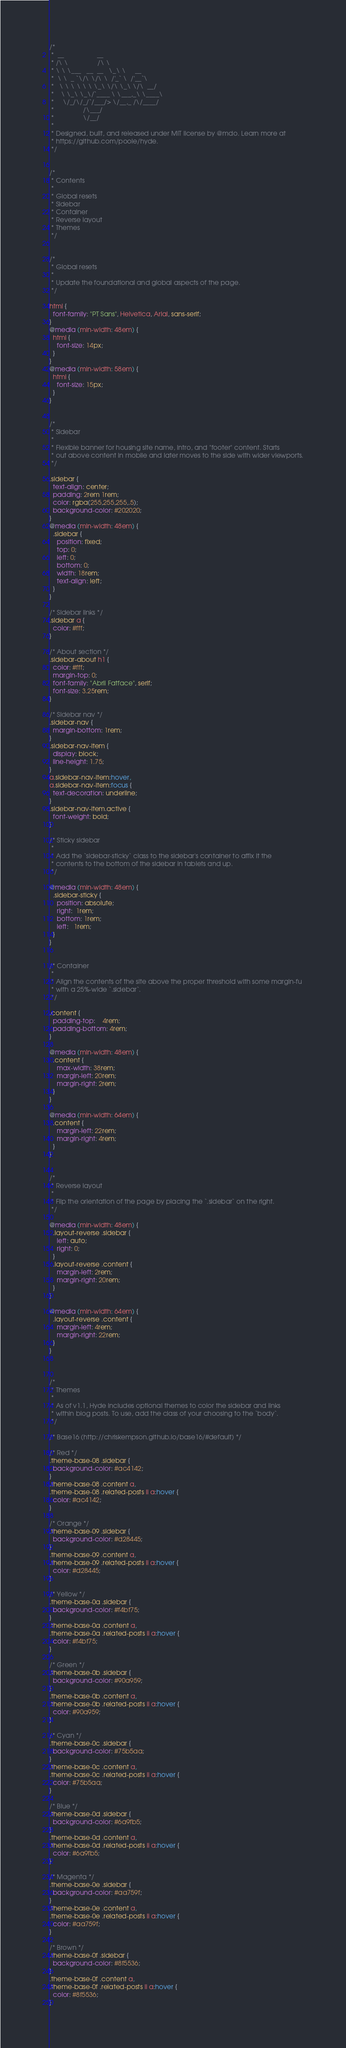Convert code to text. <code><loc_0><loc_0><loc_500><loc_500><_CSS_>/*
 *  __                  __
 * /\ \                /\ \
 * \ \ \___   __  __   \_\ \     __
 *  \ \  _ `\/\ \/\ \  /'_` \  /'__`\
 *   \ \ \ \ \ \ \_\ \/\ \_\ \/\  __/
 *    \ \_\ \_\/`____ \ \___,_\ \____\
 *     \/_/\/_/`/___/> \/__,_ /\/____/
 *                /\___/
 *                \/__/
 *
 * Designed, built, and released under MIT license by @mdo. Learn more at
 * https://github.com/poole/hyde.
 */


/*
 * Contents
 *
 * Global resets
 * Sidebar
 * Container
 * Reverse layout
 * Themes
 */


/*
 * Global resets
 *
 * Update the foundational and global aspects of the page.
 */

html {
  font-family: "PT Sans", Helvetica, Arial, sans-serif;
}
@media (min-width: 48em) {
  html {
    font-size: 14px;
  }
}
@media (min-width: 58em) {
  html {
    font-size: 15px;
  }
}


/*
 * Sidebar
 *
 * Flexible banner for housing site name, intro, and "footer" content. Starts
 * out above content in mobile and later moves to the side with wider viewports.
 */

.sidebar {
  text-align: center;
  padding: 2rem 1rem;
  color: rgba(255,255,255,.5);
  background-color: #202020;
}
@media (min-width: 48em) {
  .sidebar {
    position: fixed;
    top: 0;
    left: 0;
    bottom: 0;
    width: 18rem;
    text-align: left;
  }
}

/* Sidebar links */
.sidebar a {
  color: #fff;
}

/* About section */
.sidebar-about h1 {
  color: #fff;
  margin-top: 0;
  font-family: "Abril Fatface", serif;
  font-size: 3.25rem;
}

/* Sidebar nav */
.sidebar-nav {
  margin-bottom: 1rem;
}
.sidebar-nav-item {
  display: block;
  line-height: 1.75;
}
a.sidebar-nav-item:hover,
a.sidebar-nav-item:focus {
  text-decoration: underline;
}
.sidebar-nav-item.active {
  font-weight: bold;
}

/* Sticky sidebar
 *
 * Add the `sidebar-sticky` class to the sidebar's container to affix it the
 * contents to the bottom of the sidebar in tablets and up.
 */

@media (min-width: 48em) {
  .sidebar-sticky {
    position: absolute;
    right:  1rem;
    bottom: 1rem;
    left:   1rem;
  }
}


/* Container
 *
 * Align the contents of the site above the proper threshold with some margin-fu
 * with a 25%-wide `.sidebar`.
 */

.content {
  padding-top:    4rem;
  padding-bottom: 4rem;
}

@media (min-width: 48em) {
  .content {
    max-width: 38rem;
    margin-left: 20rem;
    margin-right: 2rem;
  }
}

@media (min-width: 64em) {
  .content {
    margin-left: 22rem;
    margin-right: 4rem;
  }
}


/*
 * Reverse layout
 *
 * Flip the orientation of the page by placing the `.sidebar` on the right.
 */

@media (min-width: 48em) {
  .layout-reverse .sidebar {
    left: auto;
    right: 0;
  }
  .layout-reverse .content {
    margin-left: 2rem;
    margin-right: 20rem;
  }
}

@media (min-width: 64em) {
  .layout-reverse .content {
    margin-left: 4rem;
    margin-right: 22rem;
  }
}



/*
 * Themes
 *
 * As of v1.1, Hyde includes optional themes to color the sidebar and links
 * within blog posts. To use, add the class of your choosing to the `body`.
 */

/* Base16 (http://chriskempson.github.io/base16/#default) */

/* Red */
.theme-base-08 .sidebar {
  background-color: #ac4142;
}
.theme-base-08 .content a,
.theme-base-08 .related-posts li a:hover {
  color: #ac4142;
}

/* Orange */
.theme-base-09 .sidebar {
  background-color: #d28445;
}
.theme-base-09 .content a,
.theme-base-09 .related-posts li a:hover {
  color: #d28445;
}

/* Yellow */
.theme-base-0a .sidebar {
  background-color: #f4bf75;
}
.theme-base-0a .content a,
.theme-base-0a .related-posts li a:hover {
  color: #f4bf75;
}

/* Green */
.theme-base-0b .sidebar {
  background-color: #90a959;
}
.theme-base-0b .content a,
.theme-base-0b .related-posts li a:hover {
  color: #90a959;
}

/* Cyan */
.theme-base-0c .sidebar {
  background-color: #75b5aa;
}
.theme-base-0c .content a,
.theme-base-0c .related-posts li a:hover {
  color: #75b5aa;
}

/* Blue */
.theme-base-0d .sidebar {
  background-color: #6a9fb5;
}
.theme-base-0d .content a,
.theme-base-0d .related-posts li a:hover {
  color: #6a9fb5;
}

/* Magenta */
.theme-base-0e .sidebar {
  background-color: #aa759f;
}
.theme-base-0e .content a,
.theme-base-0e .related-posts li a:hover {
  color: #aa759f;
}

/* Brown */
.theme-base-0f .sidebar {
  background-color: #8f5536;
}
.theme-base-0f .content a,
.theme-base-0f .related-posts li a:hover {
  color: #8f5536;
}
</code> 